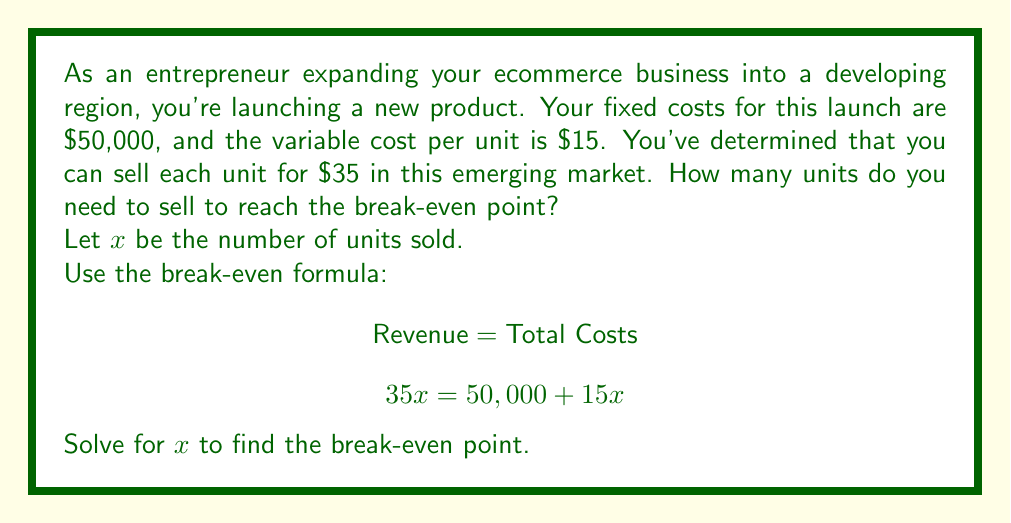Give your solution to this math problem. To solve this problem, we'll use the break-even formula and follow these steps:

1. Set up the equation:
   $$ 35x = 50,000 + 15x $$

2. Subtract 15x from both sides:
   $$ 20x = 50,000 $$

3. Divide both sides by 20:
   $$ x = \frac{50,000}{20} = 2,500 $$

The break-even point occurs when the number of units sold generates enough revenue to cover all costs (fixed and variable).

To verify:
- Revenue: $35 \times 2,500 = $87,500
- Total Costs: $50,000 + ($15 \times 2,500) = $87,500

At 2,500 units, the revenue equals the total costs, confirming the break-even point.
Answer: The break-even point is 2,500 units. 